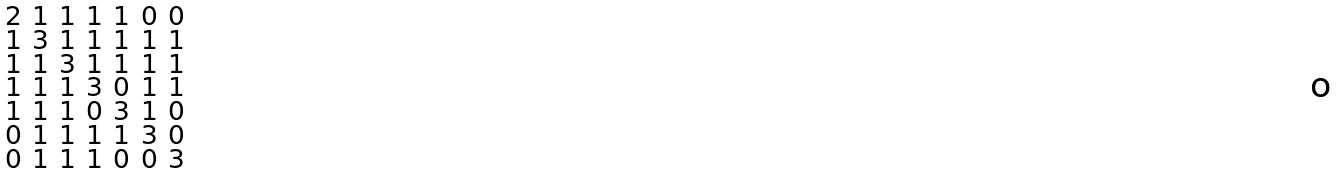<formula> <loc_0><loc_0><loc_500><loc_500>\begin{smallmatrix} 2 & 1 & 1 & 1 & 1 & 0 & 0 \\ 1 & 3 & 1 & 1 & 1 & 1 & 1 \\ 1 & 1 & 3 & 1 & 1 & 1 & 1 \\ 1 & 1 & 1 & 3 & 0 & 1 & 1 \\ 1 & 1 & 1 & 0 & 3 & 1 & 0 \\ 0 & 1 & 1 & 1 & 1 & 3 & 0 \\ 0 & 1 & 1 & 1 & 0 & 0 & 3 \end{smallmatrix}</formula> 